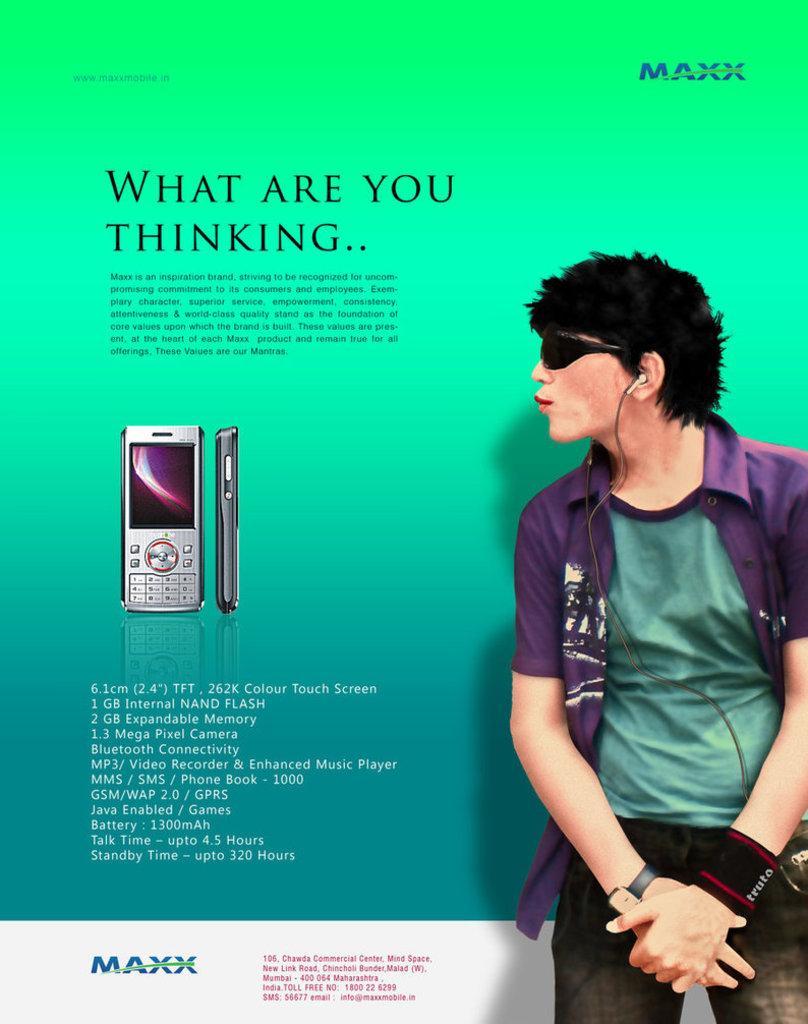How would you summarize this image in a sentence or two? In the foreground of this poster, there is a man wearing earphones and to the right side of him there is a text, mobile phones and the logo. 